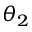Convert formula to latex. <formula><loc_0><loc_0><loc_500><loc_500>\theta _ { 2 }</formula> 